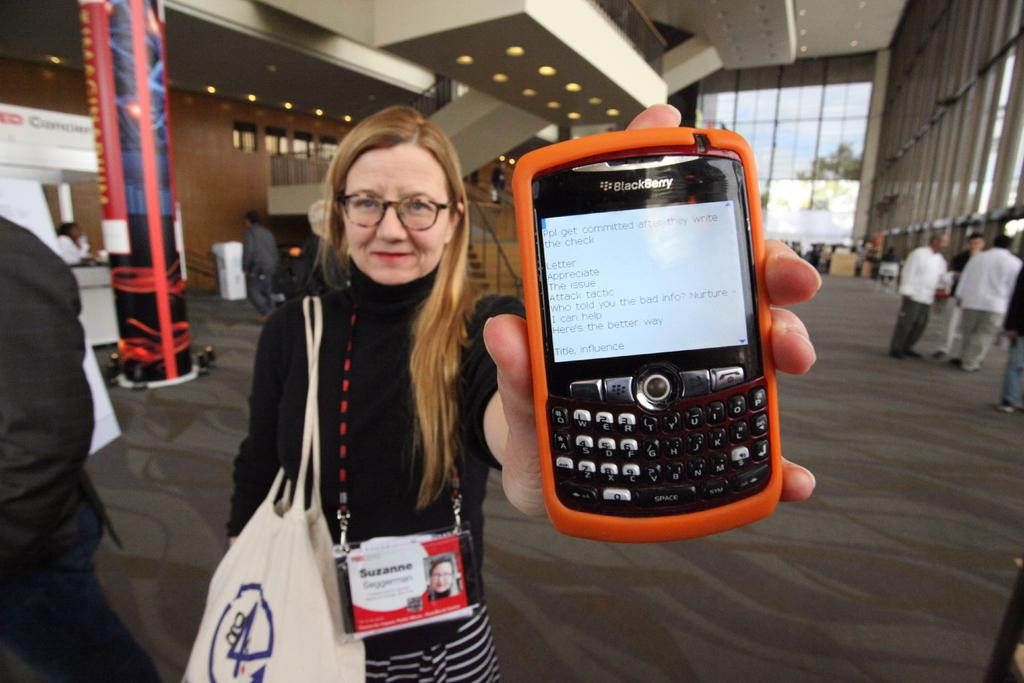<image>
Write a terse but informative summary of the picture. A woman is holding an orange Blackberry phone inside a convention hal. 